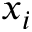Convert formula to latex. <formula><loc_0><loc_0><loc_500><loc_500>x _ { i }</formula> 